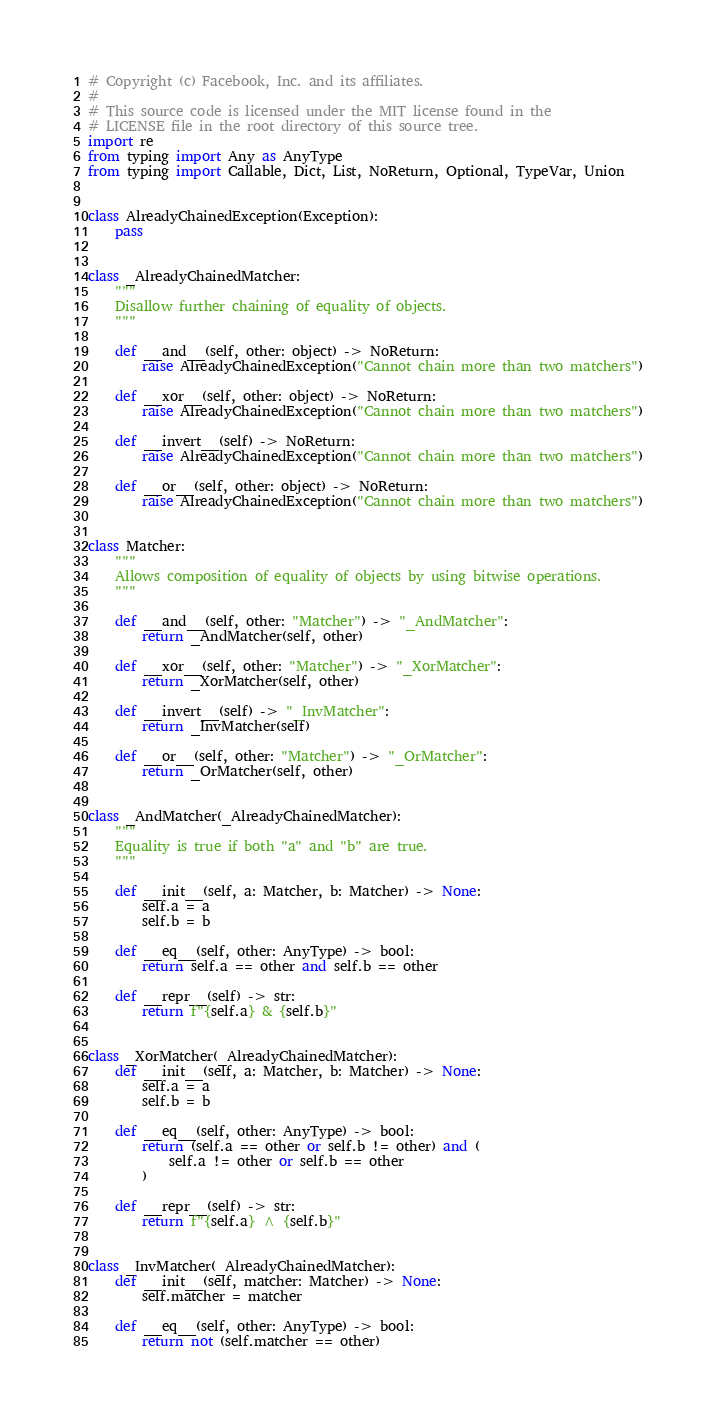Convert code to text. <code><loc_0><loc_0><loc_500><loc_500><_Python_># Copyright (c) Facebook, Inc. and its affiliates.
#
# This source code is licensed under the MIT license found in the
# LICENSE file in the root directory of this source tree.
import re
from typing import Any as AnyType
from typing import Callable, Dict, List, NoReturn, Optional, TypeVar, Union


class AlreadyChainedException(Exception):
    pass


class _AlreadyChainedMatcher:
    """
    Disallow further chaining of equality of objects.
    """

    def __and__(self, other: object) -> NoReturn:
        raise AlreadyChainedException("Cannot chain more than two matchers")

    def __xor__(self, other: object) -> NoReturn:
        raise AlreadyChainedException("Cannot chain more than two matchers")

    def __invert__(self) -> NoReturn:
        raise AlreadyChainedException("Cannot chain more than two matchers")

    def __or__(self, other: object) -> NoReturn:
        raise AlreadyChainedException("Cannot chain more than two matchers")


class Matcher:
    """
    Allows composition of equality of objects by using bitwise operations.
    """

    def __and__(self, other: "Matcher") -> "_AndMatcher":
        return _AndMatcher(self, other)

    def __xor__(self, other: "Matcher") -> "_XorMatcher":
        return _XorMatcher(self, other)

    def __invert__(self) -> "_InvMatcher":
        return _InvMatcher(self)

    def __or__(self, other: "Matcher") -> "_OrMatcher":
        return _OrMatcher(self, other)


class _AndMatcher(_AlreadyChainedMatcher):
    """
    Equality is true if both "a" and "b" are true.
    """

    def __init__(self, a: Matcher, b: Matcher) -> None:
        self.a = a
        self.b = b

    def __eq__(self, other: AnyType) -> bool:
        return self.a == other and self.b == other

    def __repr__(self) -> str:
        return f"{self.a} & {self.b}"


class _XorMatcher(_AlreadyChainedMatcher):
    def __init__(self, a: Matcher, b: Matcher) -> None:
        self.a = a
        self.b = b

    def __eq__(self, other: AnyType) -> bool:
        return (self.a == other or self.b != other) and (
            self.a != other or self.b == other
        )

    def __repr__(self) -> str:
        return f"{self.a} ^ {self.b}"


class _InvMatcher(_AlreadyChainedMatcher):
    def __init__(self, matcher: Matcher) -> None:
        self.matcher = matcher

    def __eq__(self, other: AnyType) -> bool:
        return not (self.matcher == other)
</code> 